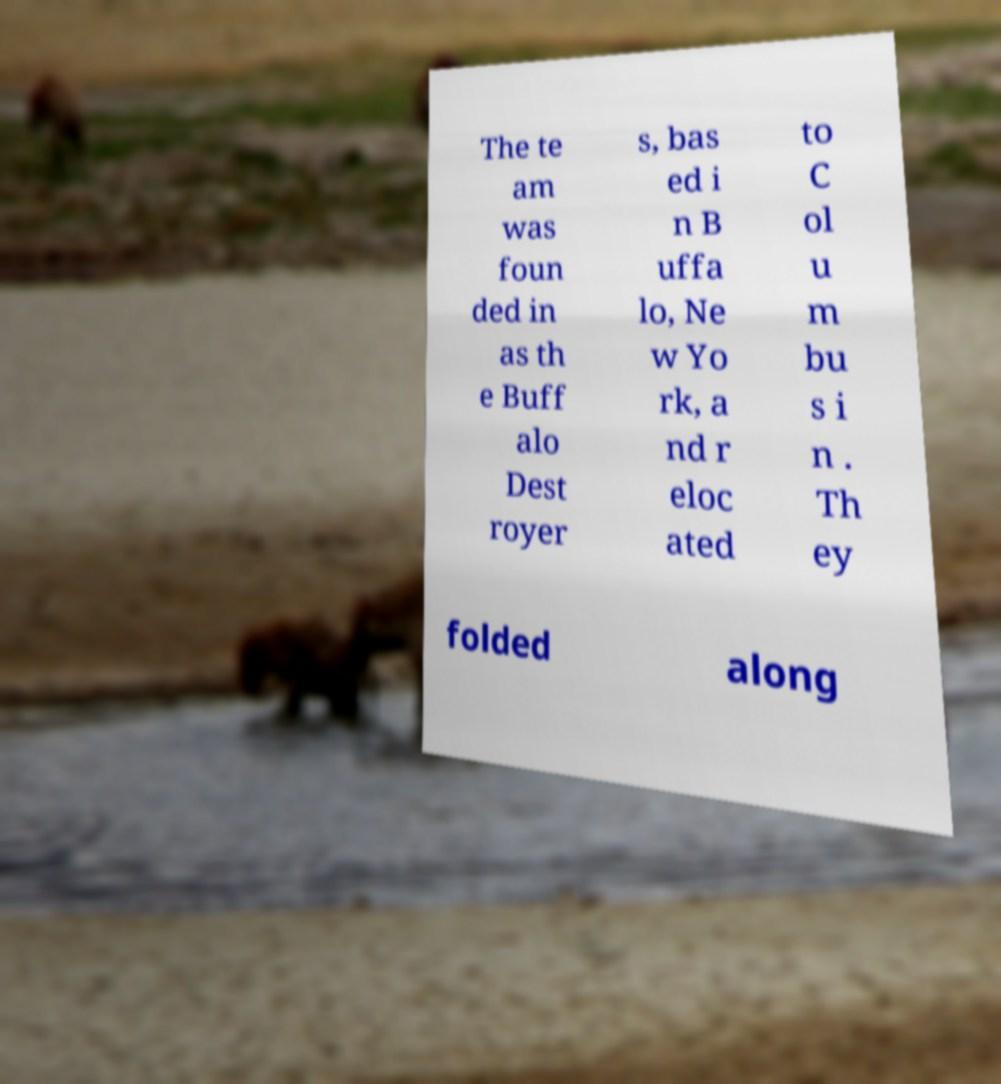Please identify and transcribe the text found in this image. The te am was foun ded in as th e Buff alo Dest royer s, bas ed i n B uffa lo, Ne w Yo rk, a nd r eloc ated to C ol u m bu s i n . Th ey folded along 